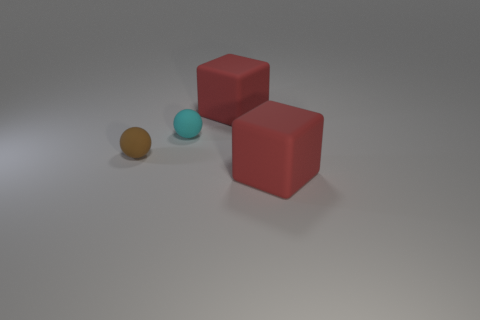Add 3 small brown spheres. How many objects exist? 7 Subtract 2 balls. How many balls are left? 0 Subtract all cyan balls. How many balls are left? 1 Subtract all brown balls. Subtract all blue blocks. How many balls are left? 1 Subtract all brown balls. Subtract all small matte things. How many objects are left? 1 Add 4 red matte things. How many red matte things are left? 6 Add 1 tiny cyan rubber things. How many tiny cyan rubber things exist? 2 Subtract 0 yellow spheres. How many objects are left? 4 